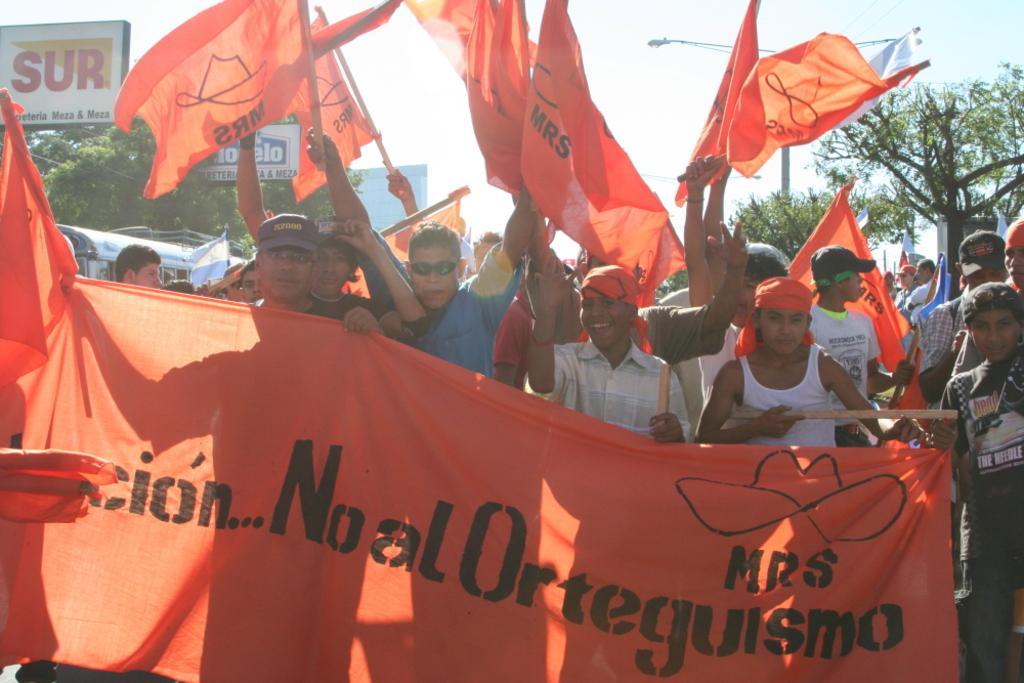Describe this image in one or two sentences. In this image, I can see a group of people standing and holding a banner and flags. Behind the people, there are boards, trees, a street light and a vehicle. In the background, there is the sky. 